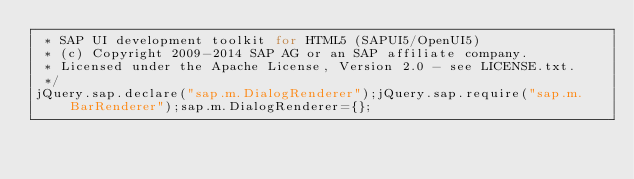Convert code to text. <code><loc_0><loc_0><loc_500><loc_500><_JavaScript_> * SAP UI development toolkit for HTML5 (SAPUI5/OpenUI5)
 * (c) Copyright 2009-2014 SAP AG or an SAP affiliate company. 
 * Licensed under the Apache License, Version 2.0 - see LICENSE.txt.
 */
jQuery.sap.declare("sap.m.DialogRenderer");jQuery.sap.require("sap.m.BarRenderer");sap.m.DialogRenderer={};</code> 